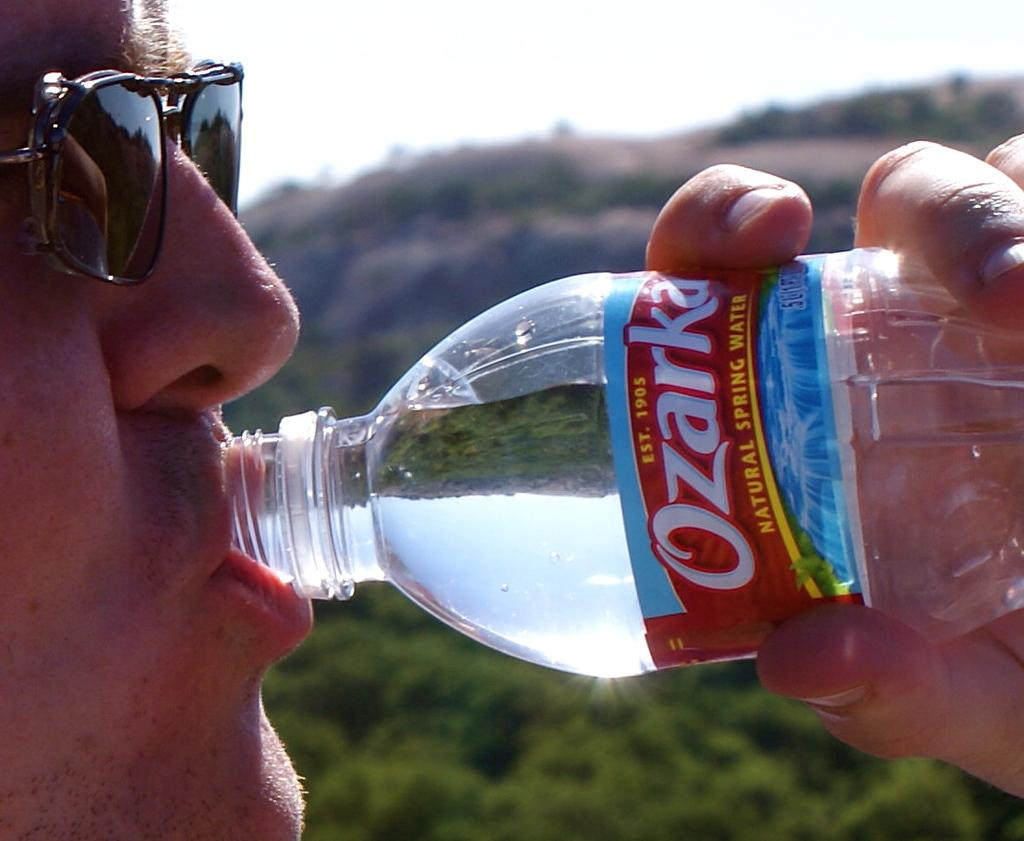Who is present in the image? There is a person in the image. What is the person wearing? The person is wearing goggles. What is the person doing in the image? The person is drinking water. What can be seen in the background of the image? There are hills and trees in the background of the image. How many copies of the mitten can be seen in the image? There is no mitten present in the image, so it is not possible to determine the number of copies. 